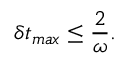<formula> <loc_0><loc_0><loc_500><loc_500>\delta t _ { \max } \leq \frac { 2 } { \omega } .</formula> 